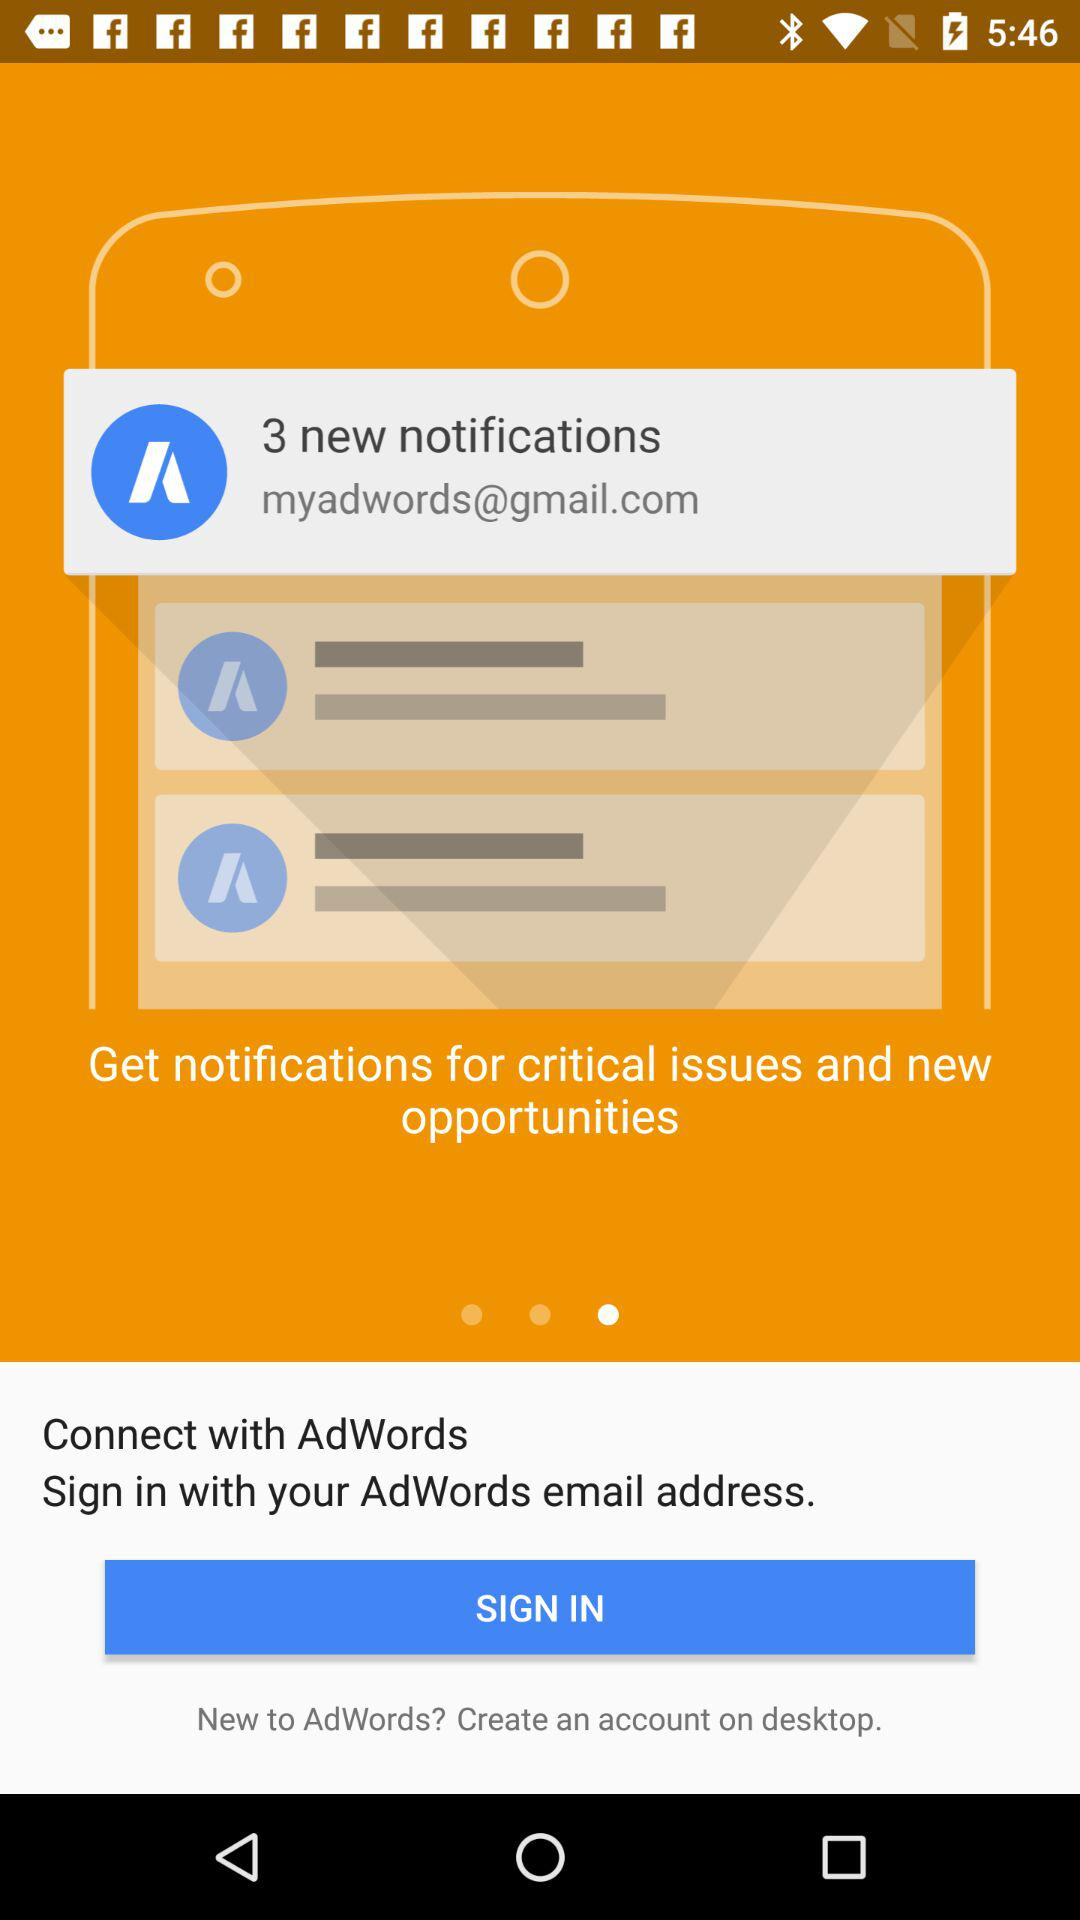What is the Gmail account? The Gmail account is myadwords@gmail.com. 